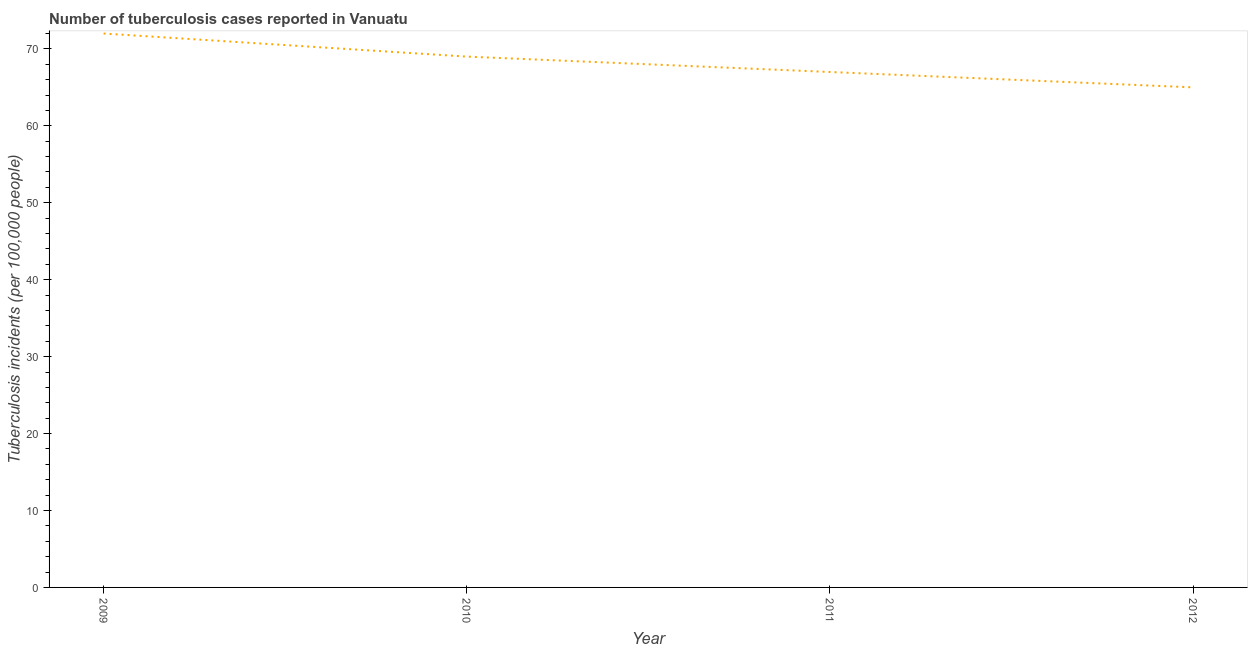What is the number of tuberculosis incidents in 2012?
Your answer should be compact. 65. Across all years, what is the maximum number of tuberculosis incidents?
Offer a terse response. 72. Across all years, what is the minimum number of tuberculosis incidents?
Provide a short and direct response. 65. In which year was the number of tuberculosis incidents minimum?
Provide a succinct answer. 2012. What is the sum of the number of tuberculosis incidents?
Your response must be concise. 273. What is the difference between the number of tuberculosis incidents in 2009 and 2010?
Your answer should be very brief. 3. What is the average number of tuberculosis incidents per year?
Give a very brief answer. 68.25. In how many years, is the number of tuberculosis incidents greater than 66 ?
Keep it short and to the point. 3. What is the ratio of the number of tuberculosis incidents in 2011 to that in 2012?
Provide a short and direct response. 1.03. Is the number of tuberculosis incidents in 2009 less than that in 2010?
Provide a short and direct response. No. What is the difference between the highest and the second highest number of tuberculosis incidents?
Your answer should be compact. 3. What is the difference between the highest and the lowest number of tuberculosis incidents?
Give a very brief answer. 7. Does the number of tuberculosis incidents monotonically increase over the years?
Provide a succinct answer. No. How many lines are there?
Provide a succinct answer. 1. Are the values on the major ticks of Y-axis written in scientific E-notation?
Your response must be concise. No. Does the graph contain grids?
Your answer should be very brief. No. What is the title of the graph?
Make the answer very short. Number of tuberculosis cases reported in Vanuatu. What is the label or title of the X-axis?
Offer a terse response. Year. What is the label or title of the Y-axis?
Provide a succinct answer. Tuberculosis incidents (per 100,0 people). What is the Tuberculosis incidents (per 100,000 people) in 2009?
Provide a short and direct response. 72. What is the Tuberculosis incidents (per 100,000 people) in 2012?
Provide a succinct answer. 65. What is the difference between the Tuberculosis incidents (per 100,000 people) in 2009 and 2011?
Provide a succinct answer. 5. What is the difference between the Tuberculosis incidents (per 100,000 people) in 2010 and 2011?
Your response must be concise. 2. What is the difference between the Tuberculosis incidents (per 100,000 people) in 2011 and 2012?
Your answer should be very brief. 2. What is the ratio of the Tuberculosis incidents (per 100,000 people) in 2009 to that in 2010?
Ensure brevity in your answer.  1.04. What is the ratio of the Tuberculosis incidents (per 100,000 people) in 2009 to that in 2011?
Offer a very short reply. 1.07. What is the ratio of the Tuberculosis incidents (per 100,000 people) in 2009 to that in 2012?
Your response must be concise. 1.11. What is the ratio of the Tuberculosis incidents (per 100,000 people) in 2010 to that in 2011?
Provide a succinct answer. 1.03. What is the ratio of the Tuberculosis incidents (per 100,000 people) in 2010 to that in 2012?
Offer a very short reply. 1.06. What is the ratio of the Tuberculosis incidents (per 100,000 people) in 2011 to that in 2012?
Give a very brief answer. 1.03. 